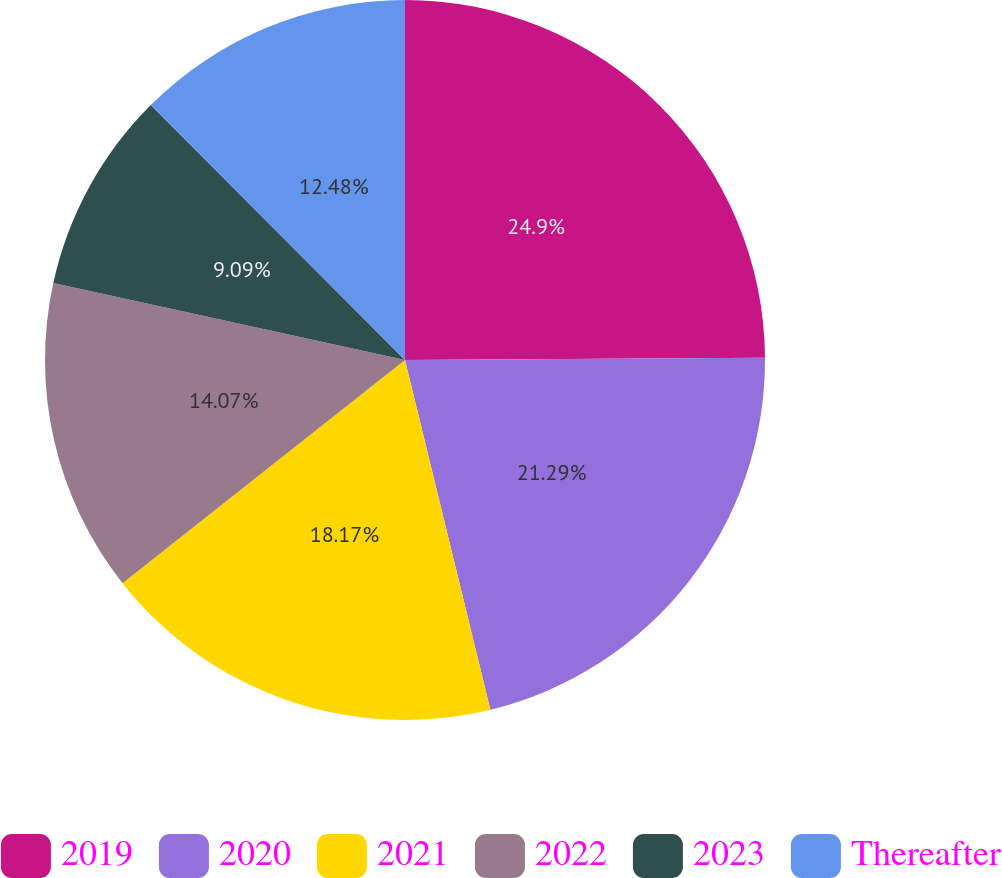<chart> <loc_0><loc_0><loc_500><loc_500><pie_chart><fcel>2019<fcel>2020<fcel>2021<fcel>2022<fcel>2023<fcel>Thereafter<nl><fcel>24.9%<fcel>21.29%<fcel>18.17%<fcel>14.07%<fcel>9.09%<fcel>12.48%<nl></chart> 